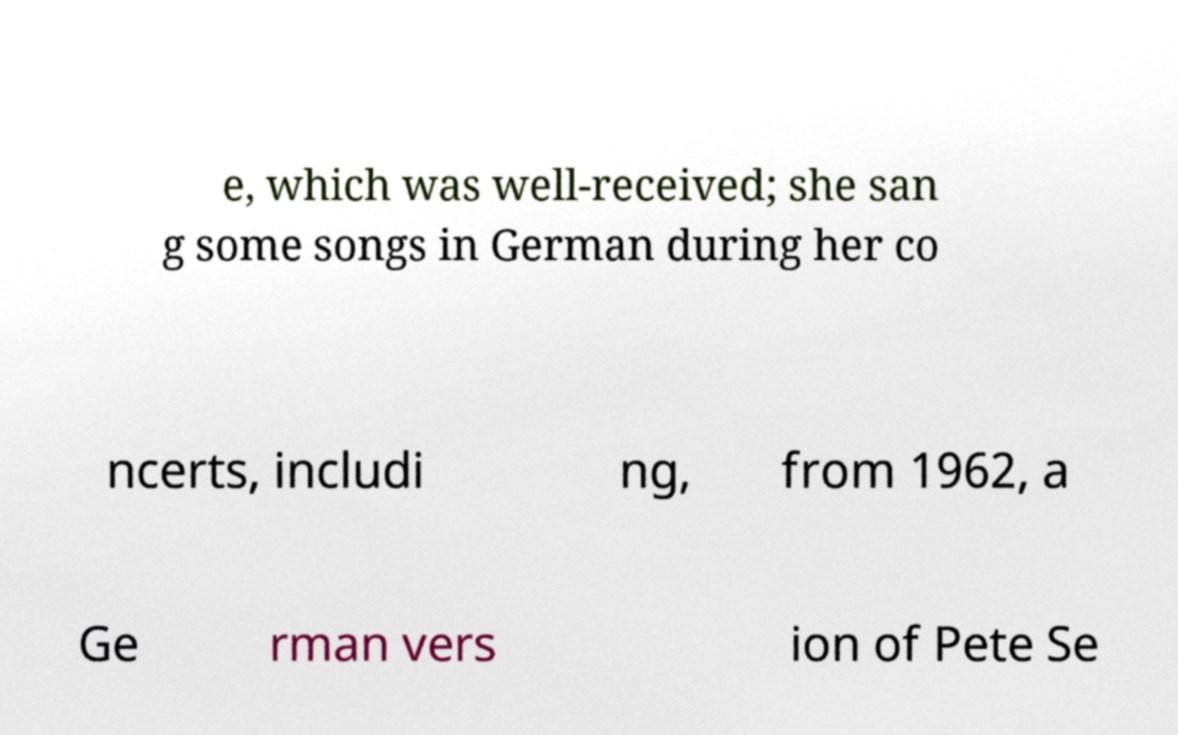Please read and relay the text visible in this image. What does it say? e, which was well-received; she san g some songs in German during her co ncerts, includi ng, from 1962, a Ge rman vers ion of Pete Se 